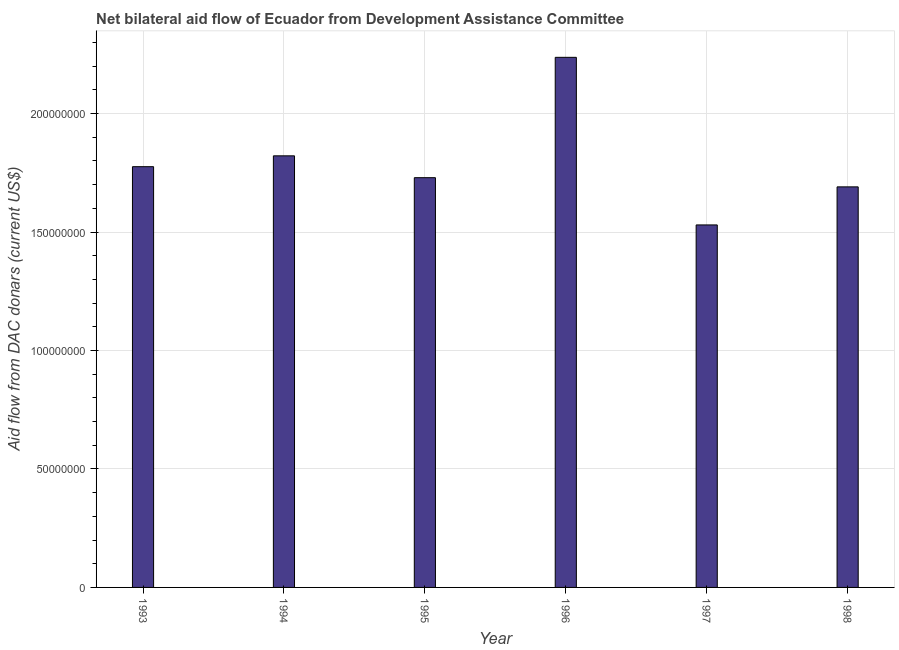Does the graph contain any zero values?
Keep it short and to the point. No. Does the graph contain grids?
Offer a terse response. Yes. What is the title of the graph?
Provide a succinct answer. Net bilateral aid flow of Ecuador from Development Assistance Committee. What is the label or title of the Y-axis?
Make the answer very short. Aid flow from DAC donars (current US$). What is the net bilateral aid flows from dac donors in 1993?
Your response must be concise. 1.78e+08. Across all years, what is the maximum net bilateral aid flows from dac donors?
Your answer should be compact. 2.24e+08. Across all years, what is the minimum net bilateral aid flows from dac donors?
Offer a terse response. 1.53e+08. In which year was the net bilateral aid flows from dac donors minimum?
Your answer should be very brief. 1997. What is the sum of the net bilateral aid flows from dac donors?
Your answer should be compact. 1.08e+09. What is the difference between the net bilateral aid flows from dac donors in 1994 and 1995?
Provide a short and direct response. 9.22e+06. What is the average net bilateral aid flows from dac donors per year?
Provide a short and direct response. 1.80e+08. What is the median net bilateral aid flows from dac donors?
Your answer should be very brief. 1.75e+08. In how many years, is the net bilateral aid flows from dac donors greater than 10000000 US$?
Provide a succinct answer. 6. What is the ratio of the net bilateral aid flows from dac donors in 1996 to that in 1998?
Your answer should be compact. 1.32. What is the difference between the highest and the second highest net bilateral aid flows from dac donors?
Your answer should be very brief. 4.16e+07. What is the difference between the highest and the lowest net bilateral aid flows from dac donors?
Provide a succinct answer. 7.07e+07. How many years are there in the graph?
Offer a very short reply. 6. Are the values on the major ticks of Y-axis written in scientific E-notation?
Give a very brief answer. No. What is the Aid flow from DAC donars (current US$) of 1993?
Give a very brief answer. 1.78e+08. What is the Aid flow from DAC donars (current US$) in 1994?
Keep it short and to the point. 1.82e+08. What is the Aid flow from DAC donars (current US$) of 1995?
Provide a short and direct response. 1.73e+08. What is the Aid flow from DAC donars (current US$) in 1996?
Your answer should be compact. 2.24e+08. What is the Aid flow from DAC donars (current US$) of 1997?
Your answer should be compact. 1.53e+08. What is the Aid flow from DAC donars (current US$) of 1998?
Give a very brief answer. 1.69e+08. What is the difference between the Aid flow from DAC donars (current US$) in 1993 and 1994?
Make the answer very short. -4.58e+06. What is the difference between the Aid flow from DAC donars (current US$) in 1993 and 1995?
Keep it short and to the point. 4.64e+06. What is the difference between the Aid flow from DAC donars (current US$) in 1993 and 1996?
Your answer should be very brief. -4.62e+07. What is the difference between the Aid flow from DAC donars (current US$) in 1993 and 1997?
Your response must be concise. 2.46e+07. What is the difference between the Aid flow from DAC donars (current US$) in 1993 and 1998?
Your answer should be very brief. 8.52e+06. What is the difference between the Aid flow from DAC donars (current US$) in 1994 and 1995?
Keep it short and to the point. 9.22e+06. What is the difference between the Aid flow from DAC donars (current US$) in 1994 and 1996?
Your response must be concise. -4.16e+07. What is the difference between the Aid flow from DAC donars (current US$) in 1994 and 1997?
Give a very brief answer. 2.92e+07. What is the difference between the Aid flow from DAC donars (current US$) in 1994 and 1998?
Make the answer very short. 1.31e+07. What is the difference between the Aid flow from DAC donars (current US$) in 1995 and 1996?
Your answer should be compact. -5.08e+07. What is the difference between the Aid flow from DAC donars (current US$) in 1995 and 1997?
Your answer should be very brief. 1.99e+07. What is the difference between the Aid flow from DAC donars (current US$) in 1995 and 1998?
Make the answer very short. 3.88e+06. What is the difference between the Aid flow from DAC donars (current US$) in 1996 and 1997?
Your answer should be compact. 7.07e+07. What is the difference between the Aid flow from DAC donars (current US$) in 1996 and 1998?
Give a very brief answer. 5.47e+07. What is the difference between the Aid flow from DAC donars (current US$) in 1997 and 1998?
Make the answer very short. -1.61e+07. What is the ratio of the Aid flow from DAC donars (current US$) in 1993 to that in 1994?
Your response must be concise. 0.97. What is the ratio of the Aid flow from DAC donars (current US$) in 1993 to that in 1995?
Your answer should be compact. 1.03. What is the ratio of the Aid flow from DAC donars (current US$) in 1993 to that in 1996?
Give a very brief answer. 0.79. What is the ratio of the Aid flow from DAC donars (current US$) in 1993 to that in 1997?
Offer a terse response. 1.16. What is the ratio of the Aid flow from DAC donars (current US$) in 1994 to that in 1995?
Ensure brevity in your answer.  1.05. What is the ratio of the Aid flow from DAC donars (current US$) in 1994 to that in 1996?
Provide a short and direct response. 0.81. What is the ratio of the Aid flow from DAC donars (current US$) in 1994 to that in 1997?
Offer a terse response. 1.19. What is the ratio of the Aid flow from DAC donars (current US$) in 1994 to that in 1998?
Your response must be concise. 1.08. What is the ratio of the Aid flow from DAC donars (current US$) in 1995 to that in 1996?
Keep it short and to the point. 0.77. What is the ratio of the Aid flow from DAC donars (current US$) in 1995 to that in 1997?
Provide a short and direct response. 1.13. What is the ratio of the Aid flow from DAC donars (current US$) in 1996 to that in 1997?
Provide a short and direct response. 1.46. What is the ratio of the Aid flow from DAC donars (current US$) in 1996 to that in 1998?
Your answer should be very brief. 1.32. What is the ratio of the Aid flow from DAC donars (current US$) in 1997 to that in 1998?
Offer a very short reply. 0.91. 